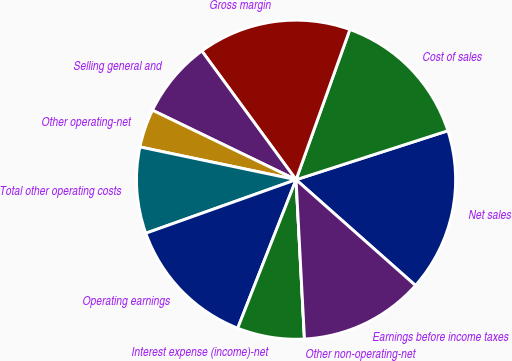Convert chart. <chart><loc_0><loc_0><loc_500><loc_500><pie_chart><fcel>Net sales<fcel>Cost of sales<fcel>Gross margin<fcel>Selling general and<fcel>Other operating-net<fcel>Total other operating costs<fcel>Operating earnings<fcel>Interest expense (income)-net<fcel>Other non-operating-net<fcel>Earnings before income taxes<nl><fcel>16.5%<fcel>14.56%<fcel>15.53%<fcel>7.77%<fcel>3.88%<fcel>8.74%<fcel>13.59%<fcel>6.8%<fcel>0.0%<fcel>12.62%<nl></chart> 